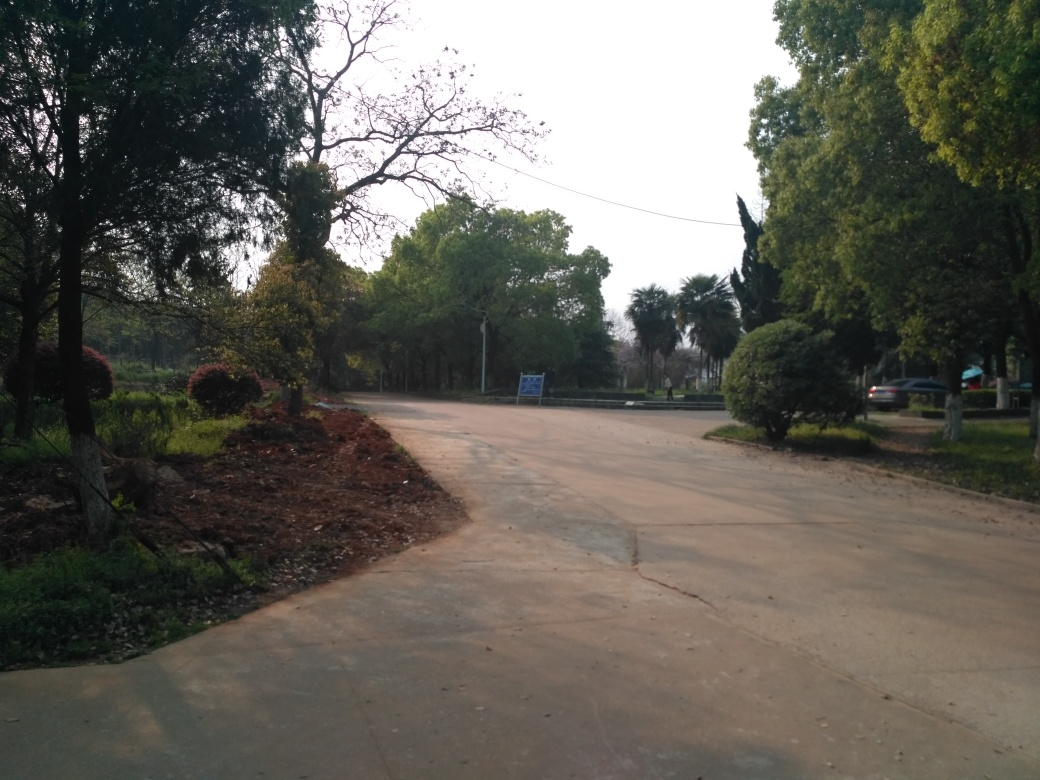What type of area is shown in this image? The image appears to show a tranquil area, likely a park or a secluded part of a suburban region. There are well-maintained pathways, lush greenery, and a variety of trees, which often typify a leisurely outdoor space designed for relaxation and casual walks. 